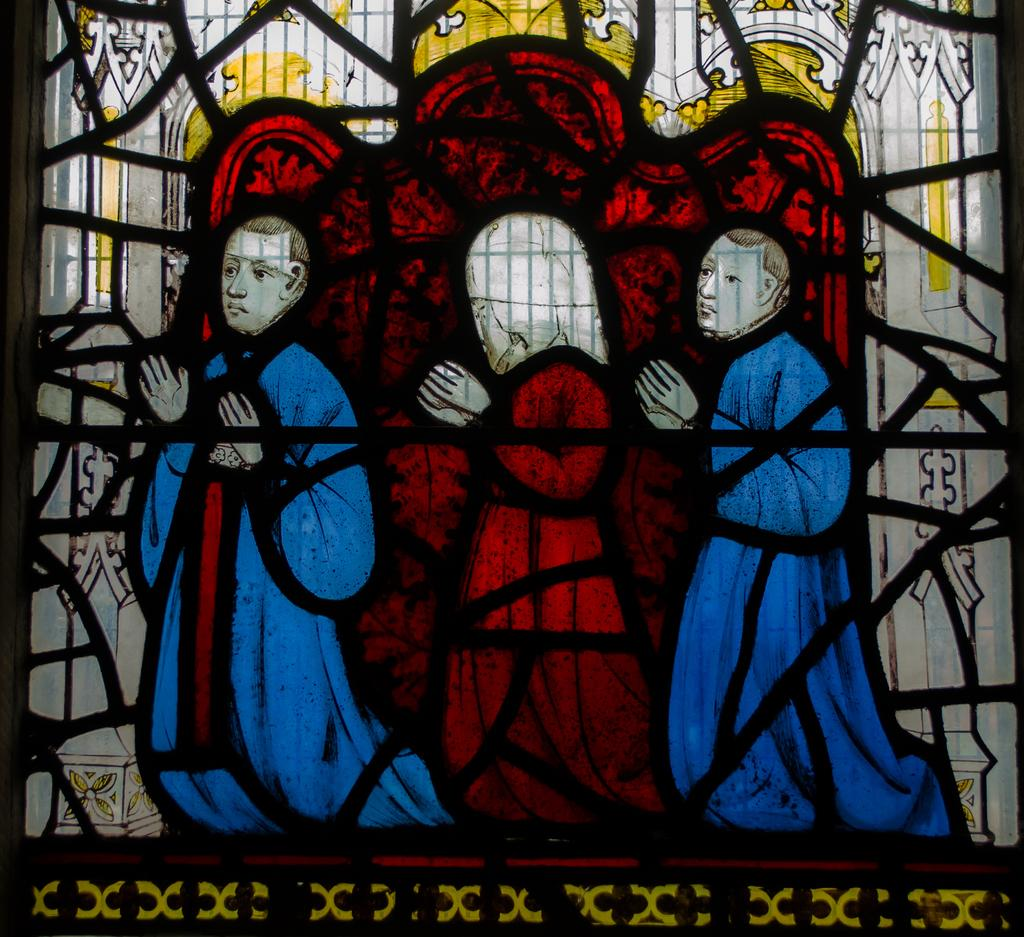What type of glass is depicted in the image? There is a stained glass in the image. What can be seen on the stained glass? The stained glass has pictures on it. How many servants are shown in the image? There are no servants present in the image; it features a stained glass with pictures on it. What type of crate is visible in the image? There is no crate present in the image. 